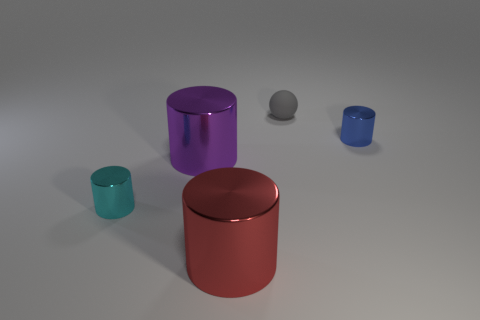What number of other things are there of the same color as the matte sphere?
Provide a succinct answer. 0. What is the material of the cyan cylinder?
Keep it short and to the point. Metal. Are there any small metallic spheres?
Your response must be concise. No. Is the number of tiny gray matte objects in front of the big purple thing the same as the number of small cyan shiny things?
Make the answer very short. No. Is there anything else that has the same material as the small gray object?
Provide a short and direct response. No. What number of large things are brown rubber things or blue things?
Your response must be concise. 0. Is the tiny cylinder left of the large red shiny cylinder made of the same material as the small gray thing?
Keep it short and to the point. No. What is the material of the tiny cylinder that is in front of the small metallic cylinder that is on the right side of the tiny gray matte ball?
Provide a short and direct response. Metal. What number of other metallic objects are the same shape as the big red object?
Offer a very short reply. 3. There is a metal object that is right of the tiny object behind the tiny cylinder that is to the right of the tiny ball; what size is it?
Provide a short and direct response. Small. 